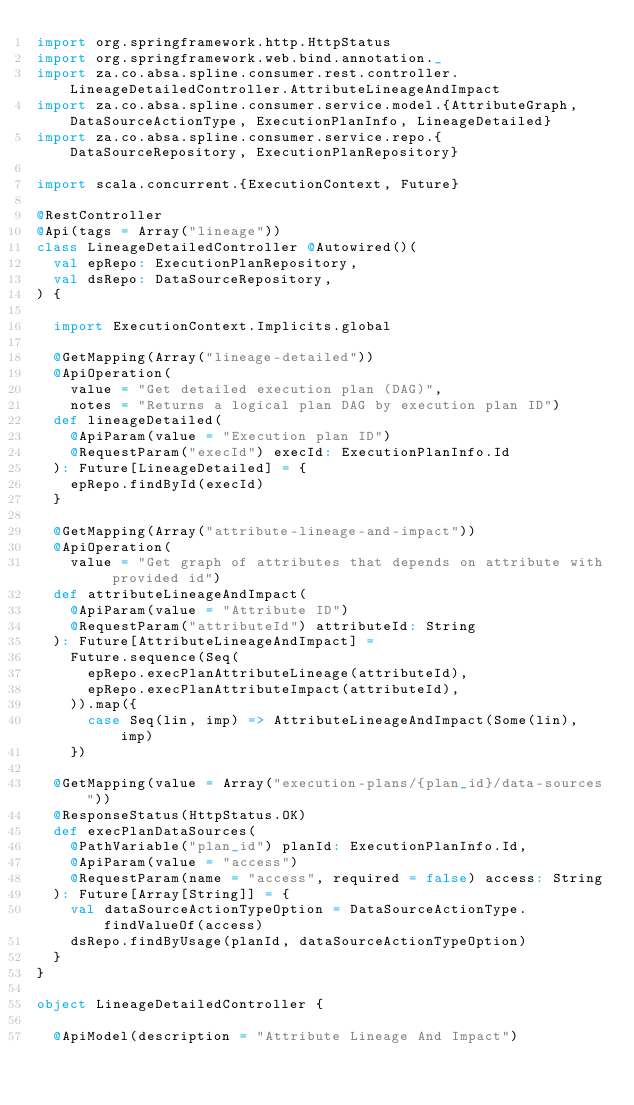Convert code to text. <code><loc_0><loc_0><loc_500><loc_500><_Scala_>import org.springframework.http.HttpStatus
import org.springframework.web.bind.annotation._
import za.co.absa.spline.consumer.rest.controller.LineageDetailedController.AttributeLineageAndImpact
import za.co.absa.spline.consumer.service.model.{AttributeGraph, DataSourceActionType, ExecutionPlanInfo, LineageDetailed}
import za.co.absa.spline.consumer.service.repo.{DataSourceRepository, ExecutionPlanRepository}

import scala.concurrent.{ExecutionContext, Future}

@RestController
@Api(tags = Array("lineage"))
class LineageDetailedController @Autowired()(
  val epRepo: ExecutionPlanRepository,
  val dsRepo: DataSourceRepository,
) {

  import ExecutionContext.Implicits.global

  @GetMapping(Array("lineage-detailed"))
  @ApiOperation(
    value = "Get detailed execution plan (DAG)",
    notes = "Returns a logical plan DAG by execution plan ID")
  def lineageDetailed(
    @ApiParam(value = "Execution plan ID")
    @RequestParam("execId") execId: ExecutionPlanInfo.Id
  ): Future[LineageDetailed] = {
    epRepo.findById(execId)
  }

  @GetMapping(Array("attribute-lineage-and-impact"))
  @ApiOperation(
    value = "Get graph of attributes that depends on attribute with provided id")
  def attributeLineageAndImpact(
    @ApiParam(value = "Attribute ID")
    @RequestParam("attributeId") attributeId: String
  ): Future[AttributeLineageAndImpact] =
    Future.sequence(Seq(
      epRepo.execPlanAttributeLineage(attributeId),
      epRepo.execPlanAttributeImpact(attributeId),
    )).map({
      case Seq(lin, imp) => AttributeLineageAndImpact(Some(lin), imp)
    })

  @GetMapping(value = Array("execution-plans/{plan_id}/data-sources"))
  @ResponseStatus(HttpStatus.OK)
  def execPlanDataSources(
    @PathVariable("plan_id") planId: ExecutionPlanInfo.Id,
    @ApiParam(value = "access")
    @RequestParam(name = "access", required = false) access: String
  ): Future[Array[String]] = {
    val dataSourceActionTypeOption = DataSourceActionType.findValueOf(access)
    dsRepo.findByUsage(planId, dataSourceActionTypeOption)
  }
}

object LineageDetailedController {

  @ApiModel(description = "Attribute Lineage And Impact")</code> 